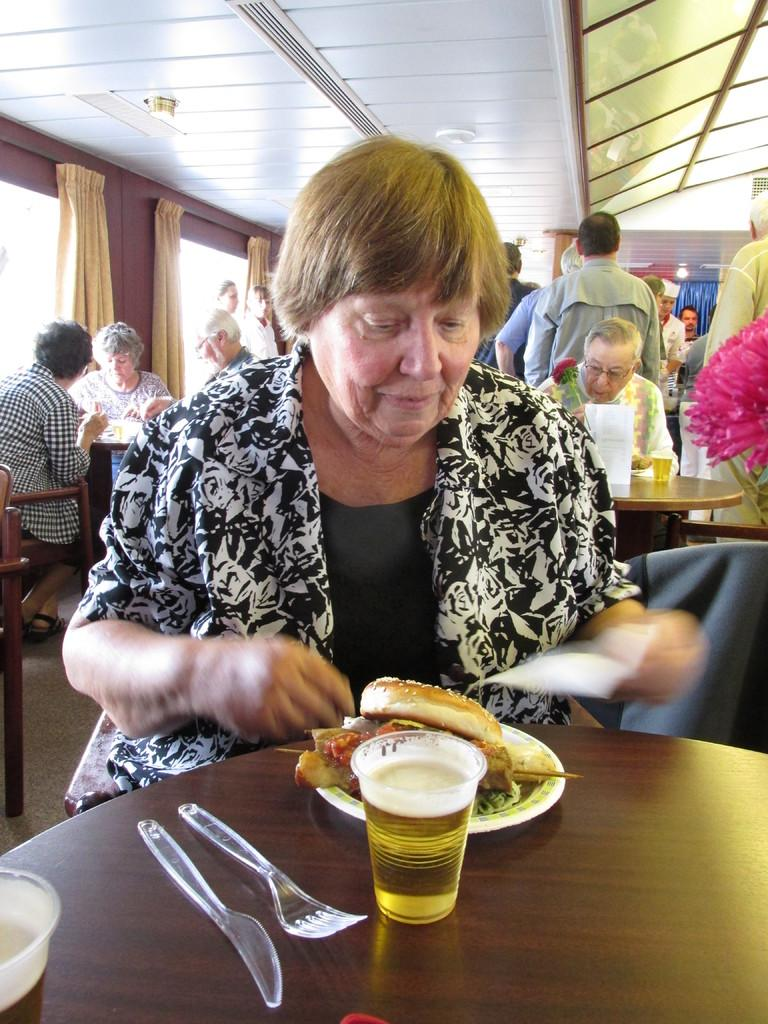Who is the main subject in the image? There is a lady in the image. What is the lady doing in the image? The lady is eating a burger. Where is the burger located? The burger is on a table. What else is on the table? There is juice on the table and spoons on the table. Are there any other people in the image? Yes, there are other people in the image. What are the other people doing? The other people are eating. What type of setting does the image appear to be? The setting appears to be a canteen. Where is the oven in the image? A: There is no oven present in the image. 